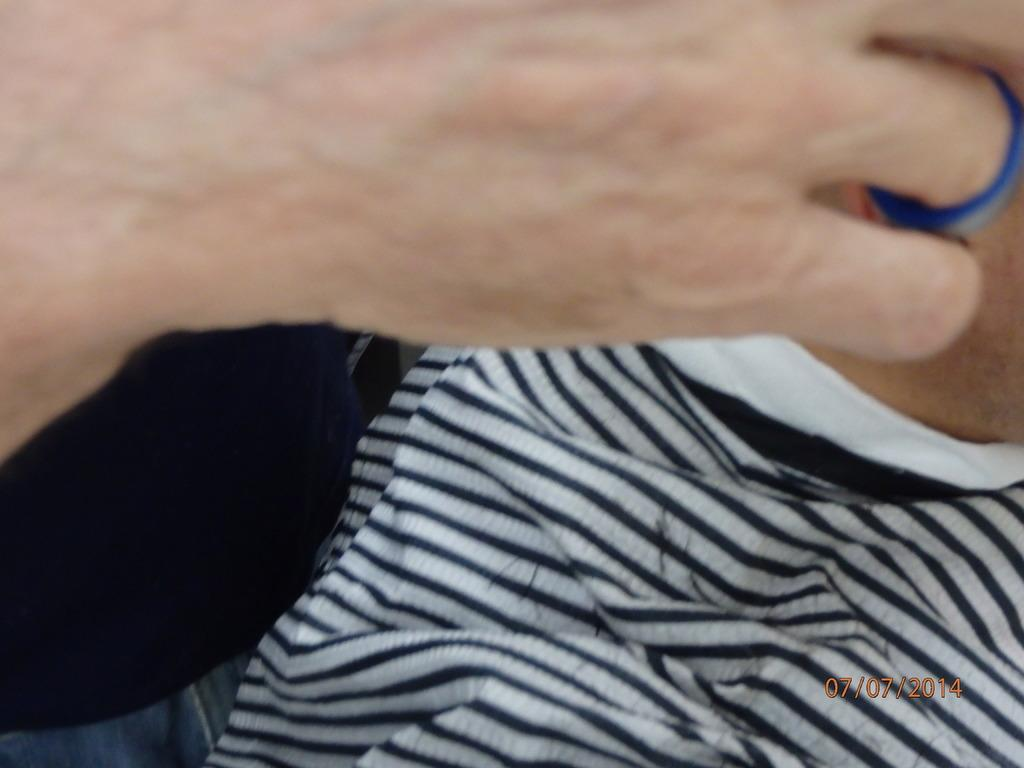What object can be seen in the image? There is a cloth in the image. Can you describe any other elements in the image? There is a person's hand at the top of the image. Is there any text or information visible in the image? Yes, there is a date in the bottom right corner of the image. How many dogs are visible in the image? There are no dogs present in the image. What type of fuel is being used by the cloth in the image? The cloth is not using any fuel, as it is an inanimate object. 